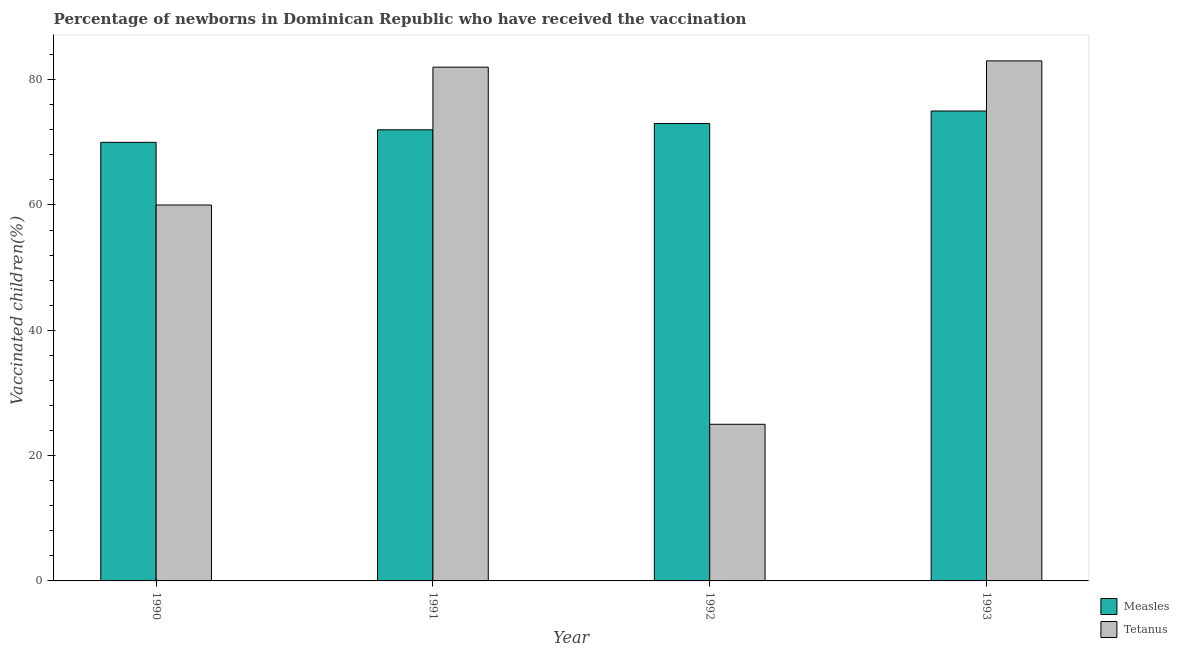How many groups of bars are there?
Your response must be concise. 4. Are the number of bars on each tick of the X-axis equal?
Your response must be concise. Yes. What is the label of the 2nd group of bars from the left?
Your answer should be very brief. 1991. In how many cases, is the number of bars for a given year not equal to the number of legend labels?
Your answer should be compact. 0. What is the percentage of newborns who received vaccination for measles in 1990?
Make the answer very short. 70. Across all years, what is the maximum percentage of newborns who received vaccination for measles?
Your response must be concise. 75. Across all years, what is the minimum percentage of newborns who received vaccination for measles?
Make the answer very short. 70. What is the total percentage of newborns who received vaccination for measles in the graph?
Your answer should be very brief. 290. What is the difference between the percentage of newborns who received vaccination for tetanus in 1990 and that in 1993?
Offer a very short reply. -23. What is the difference between the percentage of newborns who received vaccination for tetanus in 1991 and the percentage of newborns who received vaccination for measles in 1993?
Offer a terse response. -1. What is the average percentage of newborns who received vaccination for measles per year?
Your answer should be very brief. 72.5. What is the ratio of the percentage of newborns who received vaccination for tetanus in 1990 to that in 1993?
Give a very brief answer. 0.72. Is the difference between the percentage of newborns who received vaccination for tetanus in 1991 and 1993 greater than the difference between the percentage of newborns who received vaccination for measles in 1991 and 1993?
Offer a terse response. No. What is the difference between the highest and the lowest percentage of newborns who received vaccination for tetanus?
Make the answer very short. 58. In how many years, is the percentage of newborns who received vaccination for tetanus greater than the average percentage of newborns who received vaccination for tetanus taken over all years?
Your answer should be very brief. 2. What does the 1st bar from the left in 1993 represents?
Your response must be concise. Measles. What does the 2nd bar from the right in 1990 represents?
Your answer should be compact. Measles. Are all the bars in the graph horizontal?
Offer a very short reply. No. Does the graph contain any zero values?
Provide a short and direct response. No. Does the graph contain grids?
Offer a very short reply. No. What is the title of the graph?
Ensure brevity in your answer.  Percentage of newborns in Dominican Republic who have received the vaccination. Does "Urban" appear as one of the legend labels in the graph?
Your answer should be compact. No. What is the label or title of the Y-axis?
Give a very brief answer. Vaccinated children(%)
. What is the Vaccinated children(%)
 of Tetanus in 1991?
Your answer should be very brief. 82. Across all years, what is the minimum Vaccinated children(%)
 in Measles?
Ensure brevity in your answer.  70. What is the total Vaccinated children(%)
 of Measles in the graph?
Make the answer very short. 290. What is the total Vaccinated children(%)
 in Tetanus in the graph?
Provide a short and direct response. 250. What is the difference between the Vaccinated children(%)
 in Measles in 1990 and that in 1991?
Provide a succinct answer. -2. What is the difference between the Vaccinated children(%)
 of Tetanus in 1990 and that in 1991?
Make the answer very short. -22. What is the difference between the Vaccinated children(%)
 in Measles in 1990 and that in 1992?
Provide a succinct answer. -3. What is the difference between the Vaccinated children(%)
 of Tetanus in 1990 and that in 1993?
Provide a succinct answer. -23. What is the difference between the Vaccinated children(%)
 of Measles in 1991 and that in 1993?
Your answer should be compact. -3. What is the difference between the Vaccinated children(%)
 of Measles in 1992 and that in 1993?
Your answer should be compact. -2. What is the difference between the Vaccinated children(%)
 in Tetanus in 1992 and that in 1993?
Provide a short and direct response. -58. What is the difference between the Vaccinated children(%)
 of Measles in 1990 and the Vaccinated children(%)
 of Tetanus in 1992?
Ensure brevity in your answer.  45. What is the difference between the Vaccinated children(%)
 in Measles in 1991 and the Vaccinated children(%)
 in Tetanus in 1993?
Give a very brief answer. -11. What is the average Vaccinated children(%)
 in Measles per year?
Keep it short and to the point. 72.5. What is the average Vaccinated children(%)
 in Tetanus per year?
Your answer should be compact. 62.5. In the year 1991, what is the difference between the Vaccinated children(%)
 of Measles and Vaccinated children(%)
 of Tetanus?
Your answer should be very brief. -10. In the year 1992, what is the difference between the Vaccinated children(%)
 of Measles and Vaccinated children(%)
 of Tetanus?
Offer a very short reply. 48. In the year 1993, what is the difference between the Vaccinated children(%)
 of Measles and Vaccinated children(%)
 of Tetanus?
Provide a succinct answer. -8. What is the ratio of the Vaccinated children(%)
 of Measles in 1990 to that in 1991?
Provide a succinct answer. 0.97. What is the ratio of the Vaccinated children(%)
 in Tetanus in 1990 to that in 1991?
Your answer should be very brief. 0.73. What is the ratio of the Vaccinated children(%)
 of Measles in 1990 to that in 1992?
Give a very brief answer. 0.96. What is the ratio of the Vaccinated children(%)
 in Measles in 1990 to that in 1993?
Provide a succinct answer. 0.93. What is the ratio of the Vaccinated children(%)
 of Tetanus in 1990 to that in 1993?
Your response must be concise. 0.72. What is the ratio of the Vaccinated children(%)
 of Measles in 1991 to that in 1992?
Your answer should be compact. 0.99. What is the ratio of the Vaccinated children(%)
 of Tetanus in 1991 to that in 1992?
Keep it short and to the point. 3.28. What is the ratio of the Vaccinated children(%)
 in Measles in 1991 to that in 1993?
Your answer should be very brief. 0.96. What is the ratio of the Vaccinated children(%)
 of Measles in 1992 to that in 1993?
Give a very brief answer. 0.97. What is the ratio of the Vaccinated children(%)
 in Tetanus in 1992 to that in 1993?
Offer a very short reply. 0.3. What is the difference between the highest and the lowest Vaccinated children(%)
 of Measles?
Your response must be concise. 5. 